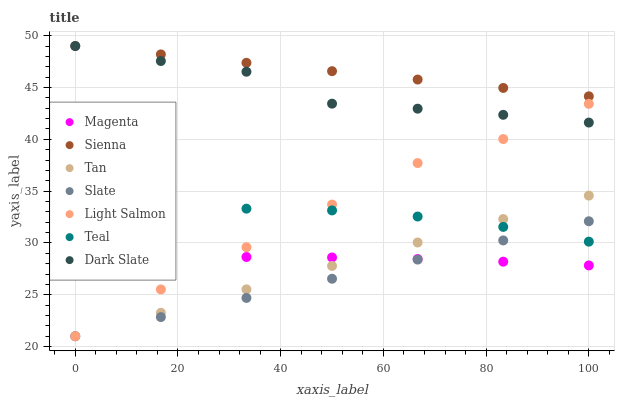Does Slate have the minimum area under the curve?
Answer yes or no. Yes. Does Sienna have the maximum area under the curve?
Answer yes or no. Yes. Does Sienna have the minimum area under the curve?
Answer yes or no. No. Does Slate have the maximum area under the curve?
Answer yes or no. No. Is Slate the smoothest?
Answer yes or no. Yes. Is Dark Slate the roughest?
Answer yes or no. Yes. Is Sienna the smoothest?
Answer yes or no. No. Is Sienna the roughest?
Answer yes or no. No. Does Light Salmon have the lowest value?
Answer yes or no. Yes. Does Sienna have the lowest value?
Answer yes or no. No. Does Dark Slate have the highest value?
Answer yes or no. Yes. Does Slate have the highest value?
Answer yes or no. No. Is Tan less than Sienna?
Answer yes or no. Yes. Is Teal greater than Magenta?
Answer yes or no. Yes. Does Magenta intersect Tan?
Answer yes or no. Yes. Is Magenta less than Tan?
Answer yes or no. No. Is Magenta greater than Tan?
Answer yes or no. No. Does Tan intersect Sienna?
Answer yes or no. No. 